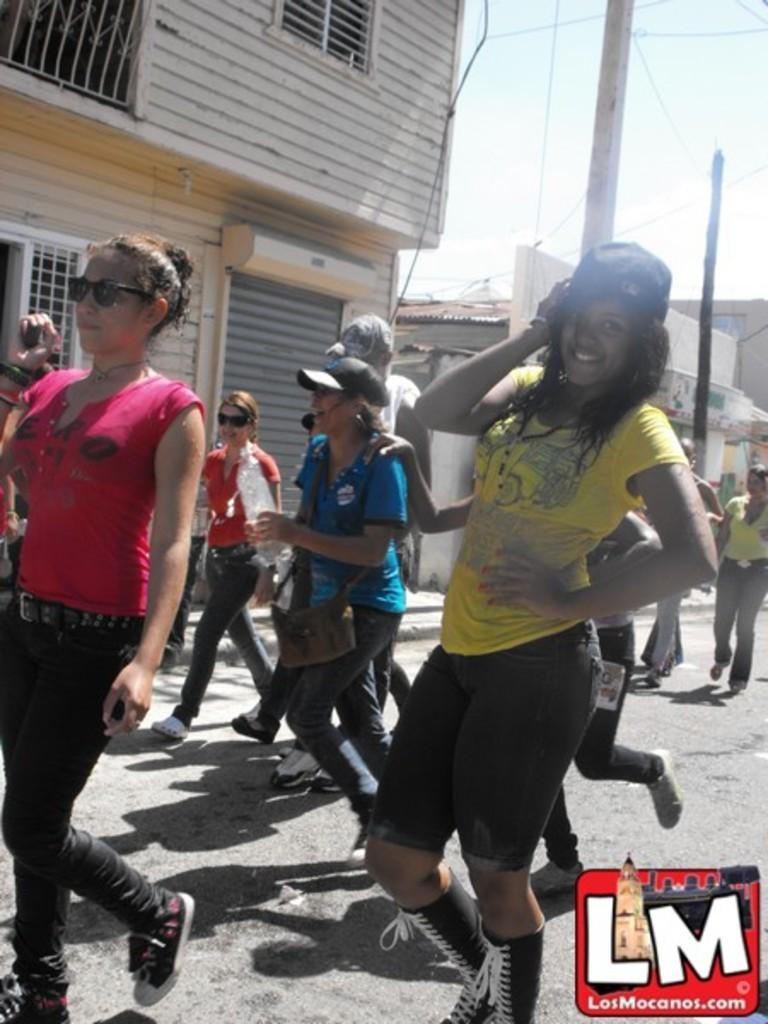Please provide a concise description of this image. In this image there are persons walking. In the front the woman is smiling wearing a yellow colour t-shirt. In the background there are buildings, poles and the sky is cloudy. 